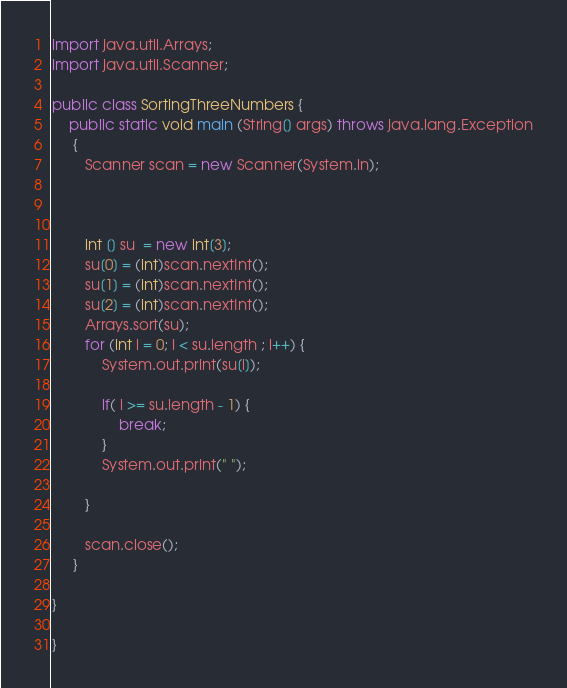<code> <loc_0><loc_0><loc_500><loc_500><_Java_>import java.util.Arrays;
import java.util.Scanner;

public class SortingThreeNumbers {
	public static void main (String[] args) throws java.lang.Exception
	 {
		Scanner scan = new Scanner(System.in);



		int [] su  = new int[3];
		su[0] = (int)scan.nextInt();
		su[1] = (int)scan.nextInt();
		su[2] = (int)scan.nextInt();
		Arrays.sort(su);
		for (int i = 0; i < su.length ; i++) {
			System.out.print(su[i]);

			if( i >= su.length - 1) {
				break;
			}
			System.out.print(" ");

		}
			
		scan.close();
	 }

}

}

</code> 